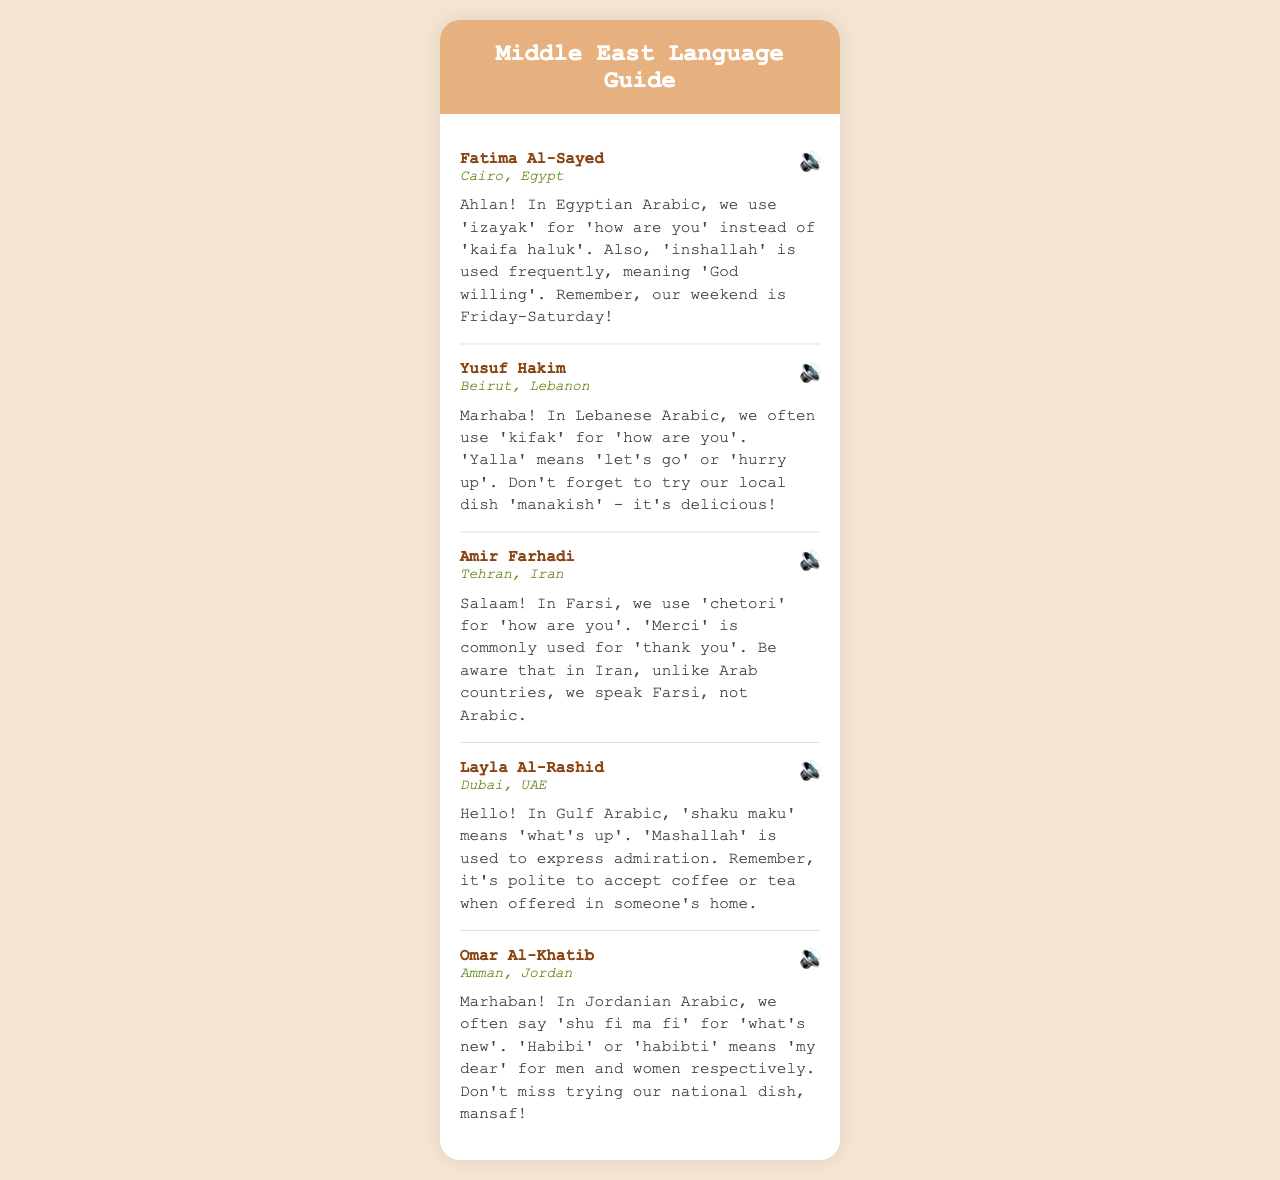what is the name of the contact from Cairo? The document provides the name of the contact from Cairo, which is mentioned in the first voice message.
Answer: Fatima Al-Sayed what phrase is used in Egyptian Arabic for 'how are you'? The voice message from Fatima Al-Sayed specifies the phrase commonly used in Egyptian Arabic for this greeting.
Answer: izayak which city is associated with the speaker Amir Farhadi? The location mentioned in the message from Amir Farhadi indicates where he is based.
Answer: Tehran what is a popular dish to try in Lebanon? Yusuf Hakim's message includes a recommendation for a traditional dish from Lebanon.
Answer: manakish which expression means 'what's new' in Jordanian Arabic? The voice message from Omar Al-Khatib specifies a common expression used in Jordanian Arabic.
Answer: shu fi ma fi how do you say 'thank you' in Farsi? Amir Farhadi's message includes a commonly used word for gratitude in Farsi.
Answer: Merci what is the weekend in Egypt? Fatima Al-Sayed notes the days considered the weekend in her country.
Answer: Friday-Saturday which phrase is used in Gulf Arabic to ask 'what's up'? Layla Al-Rashid provides a localized expression for this greeting in her message.
Answer: shaku maku what does 'habibi' mean? Omar Al-Khatib describes the meaning of this term used in Jordan.
Answer: my dear 